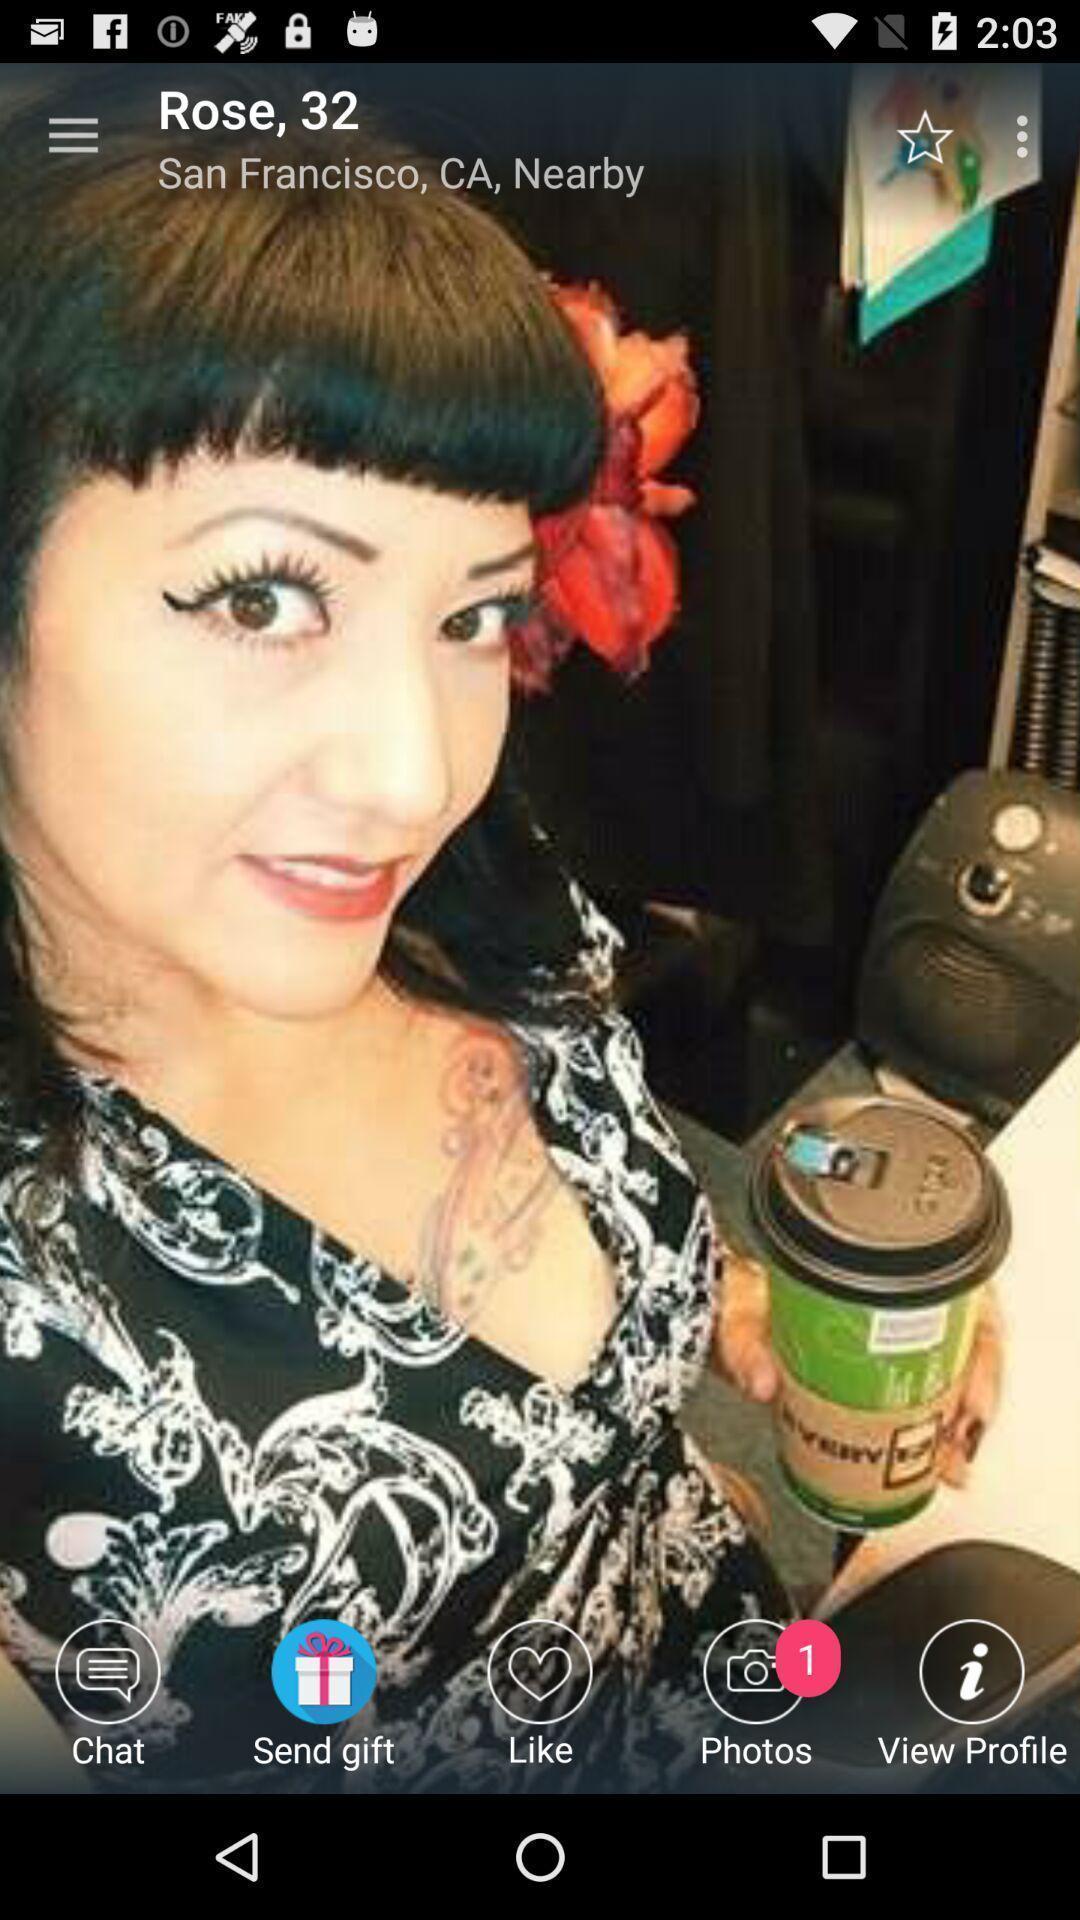Tell me about the visual elements in this screen capture. Profile photo is being displayed in the application. 